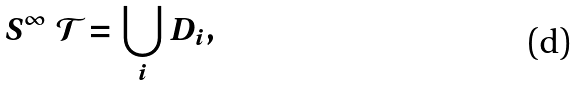Convert formula to latex. <formula><loc_0><loc_0><loc_500><loc_500>S ^ { \infty } \ \mathcal { T } = \bigcup _ { i } D _ { i } ,</formula> 